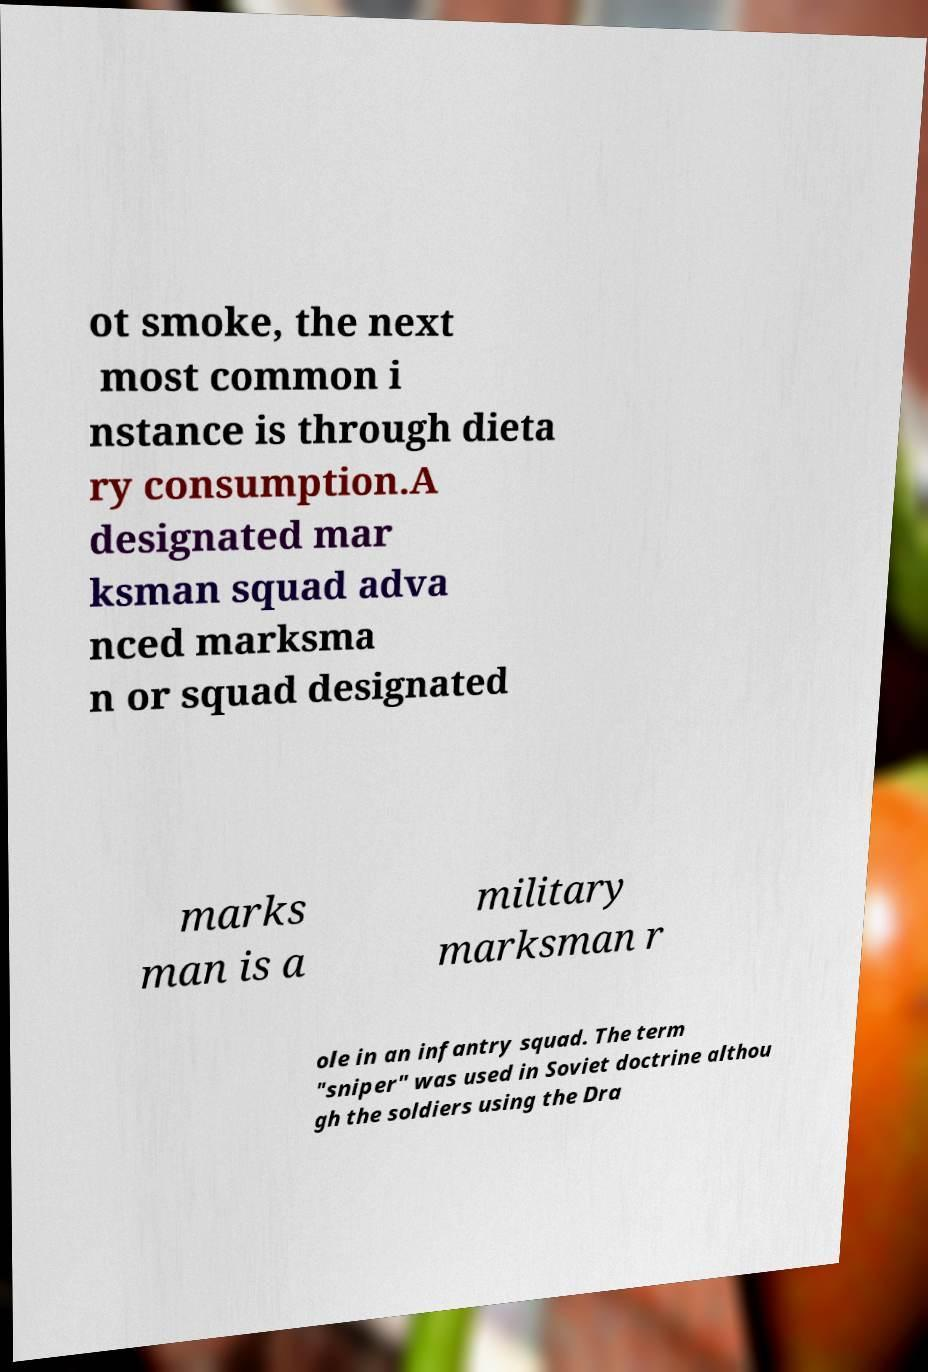What messages or text are displayed in this image? I need them in a readable, typed format. ot smoke, the next most common i nstance is through dieta ry consumption.A designated mar ksman squad adva nced marksma n or squad designated marks man is a military marksman r ole in an infantry squad. The term "sniper" was used in Soviet doctrine althou gh the soldiers using the Dra 